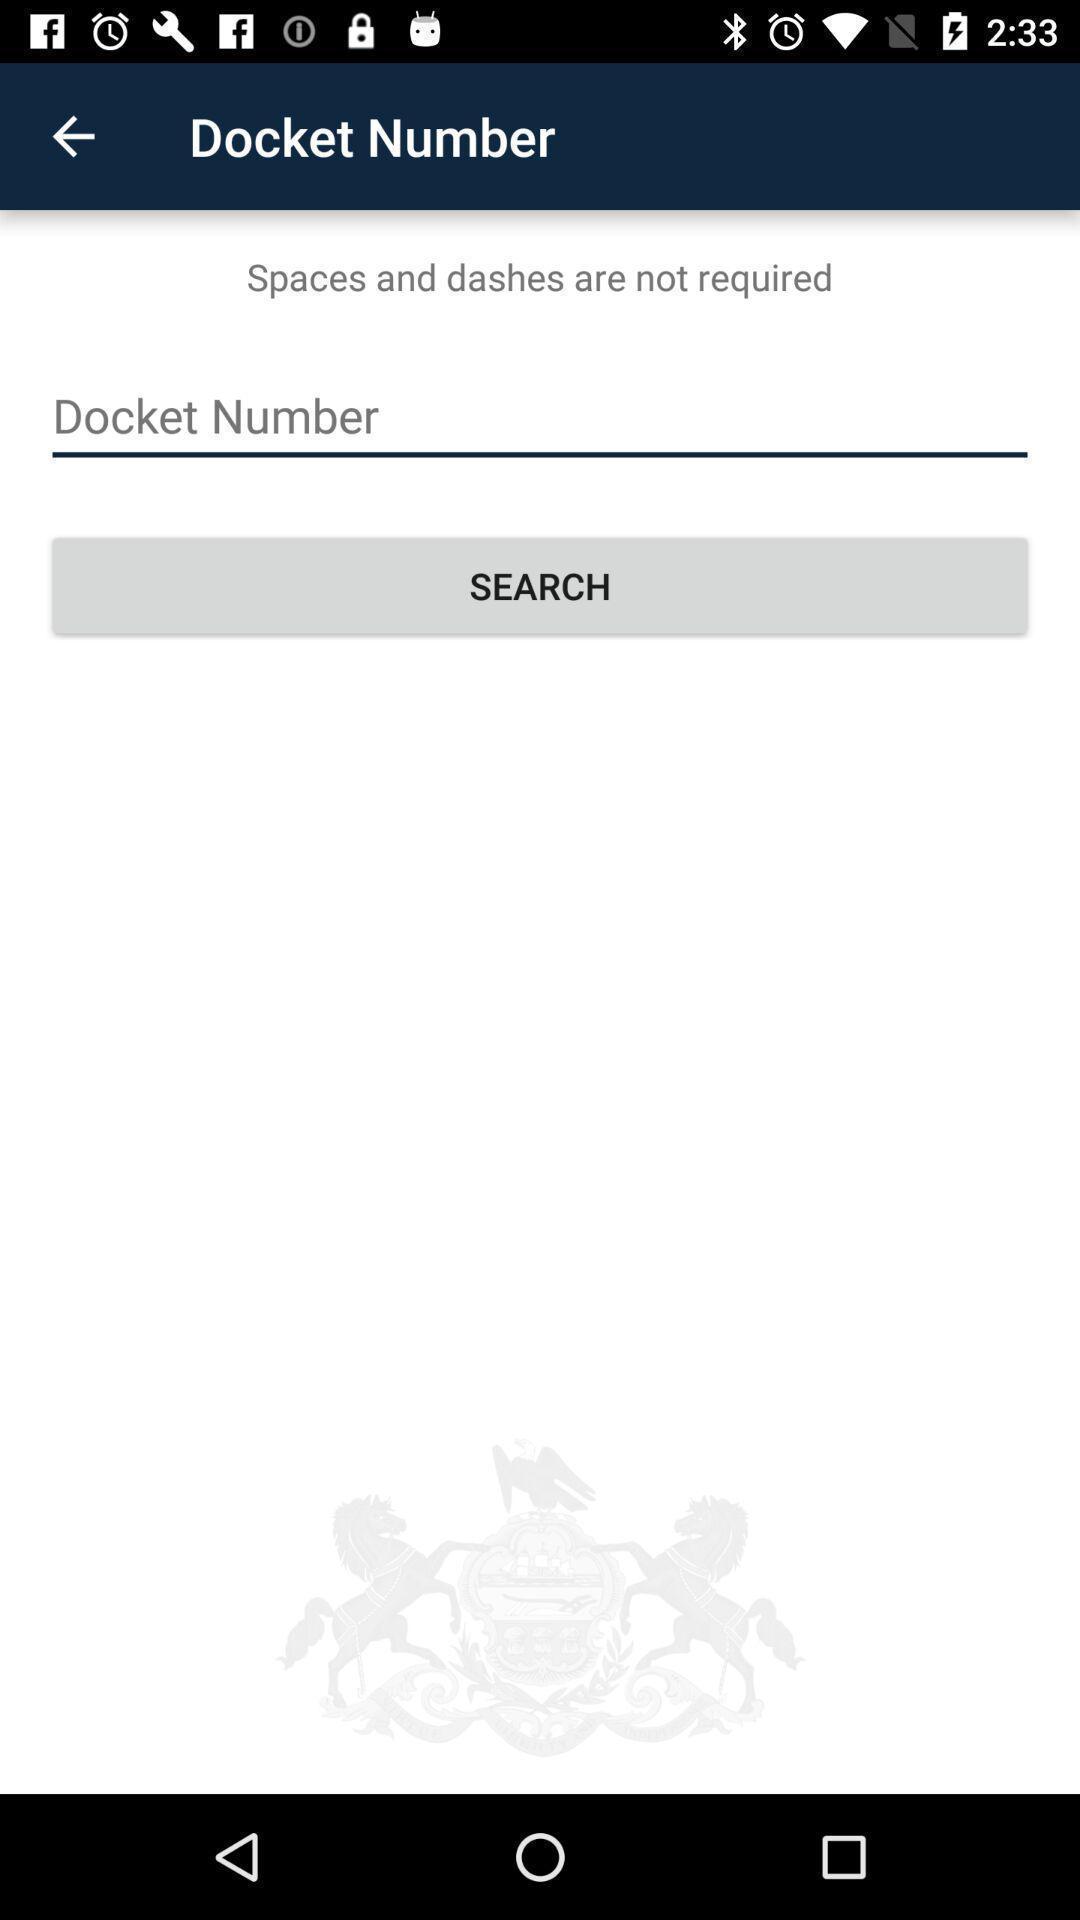Summarize the main components in this picture. Search page displaying to enter number. 